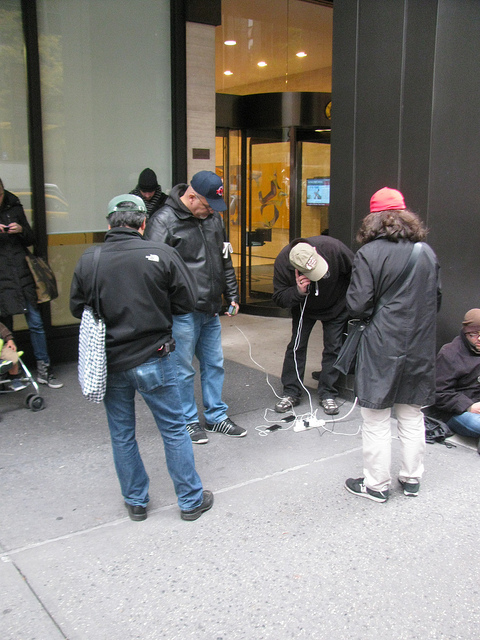Where is the bench? I've checked thoroughly, but there is no bench visible in the image. Let me know if there's something else in the picture you're curious about! 